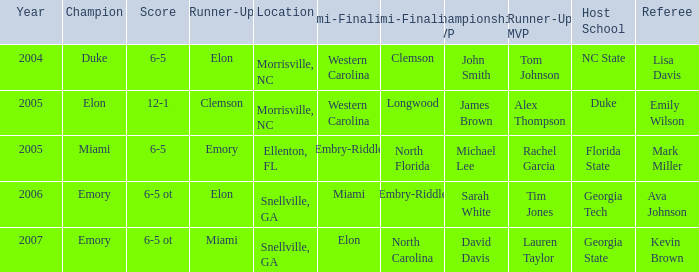Parse the table in full. {'header': ['Year', 'Champion', 'Score', 'Runner-Up', 'Location', 'Semi-Finalist #1', 'Semi-Finalist #2', 'Championship MVP', 'Runner-Up MVP', 'Host School', 'Referee'], 'rows': [['2004', 'Duke', '6-5', 'Elon', 'Morrisville, NC', 'Western Carolina', 'Clemson', 'John Smith', 'Tom Johnson', 'NC State', 'Lisa Davis'], ['2005', 'Elon', '12-1', 'Clemson', 'Morrisville, NC', 'Western Carolina', 'Longwood', 'James Brown', 'Alex Thompson', 'Duke', 'Emily Wilson'], ['2005', 'Miami', '6-5', 'Emory', 'Ellenton, FL', 'Embry-Riddle', 'North Florida', 'Michael Lee', 'Rachel Garcia', 'Florida State', 'Mark Miller'], ['2006', 'Emory', '6-5 ot', 'Elon', 'Snellville, GA', 'Miami', 'Embry-Riddle', 'Sarah White', 'Tim Jones', 'Georgia Tech', 'Ava Johnson'], ['2007', 'Emory', '6-5 ot', 'Miami', 'Snellville, GA', 'Elon', 'North Carolina', 'David Davis', 'Lauren Taylor', 'Georgia State', 'Kevin Brown']]} In 2005, with western carolina as the first semi-finalist, how many teams were documented as runner-up? 1.0. 